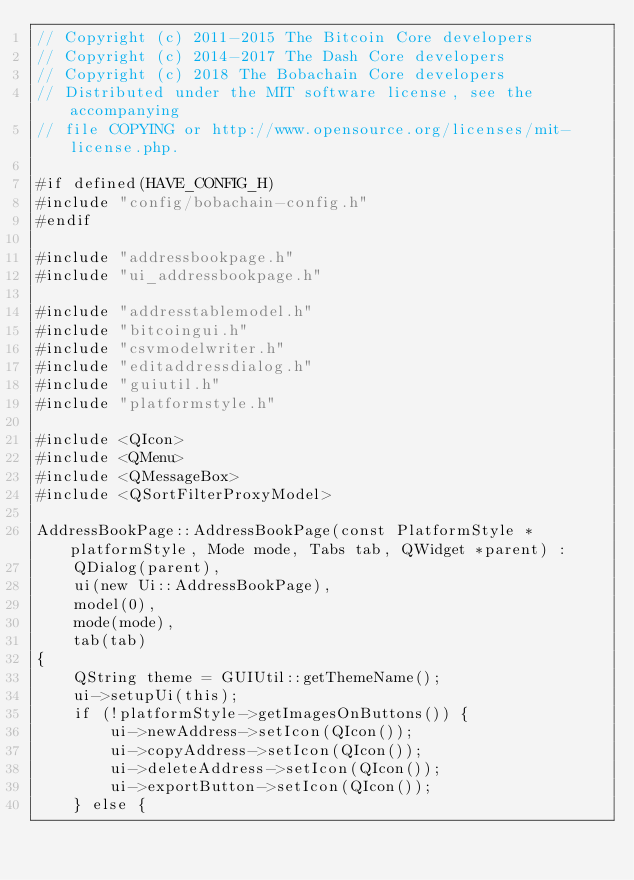Convert code to text. <code><loc_0><loc_0><loc_500><loc_500><_C++_>// Copyright (c) 2011-2015 The Bitcoin Core developers
// Copyright (c) 2014-2017 The Dash Core developers
// Copyright (c) 2018 The Bobachain Core developers
// Distributed under the MIT software license, see the accompanying
// file COPYING or http://www.opensource.org/licenses/mit-license.php.

#if defined(HAVE_CONFIG_H)
#include "config/bobachain-config.h"
#endif

#include "addressbookpage.h"
#include "ui_addressbookpage.h"

#include "addresstablemodel.h"
#include "bitcoingui.h"
#include "csvmodelwriter.h"
#include "editaddressdialog.h"
#include "guiutil.h"
#include "platformstyle.h"

#include <QIcon>
#include <QMenu>
#include <QMessageBox>
#include <QSortFilterProxyModel>

AddressBookPage::AddressBookPage(const PlatformStyle *platformStyle, Mode mode, Tabs tab, QWidget *parent) :
    QDialog(parent),
    ui(new Ui::AddressBookPage),
    model(0),
    mode(mode),
    tab(tab)
{
    QString theme = GUIUtil::getThemeName();
    ui->setupUi(this);
    if (!platformStyle->getImagesOnButtons()) {
        ui->newAddress->setIcon(QIcon());
        ui->copyAddress->setIcon(QIcon());
        ui->deleteAddress->setIcon(QIcon());
        ui->exportButton->setIcon(QIcon());
    } else {</code> 